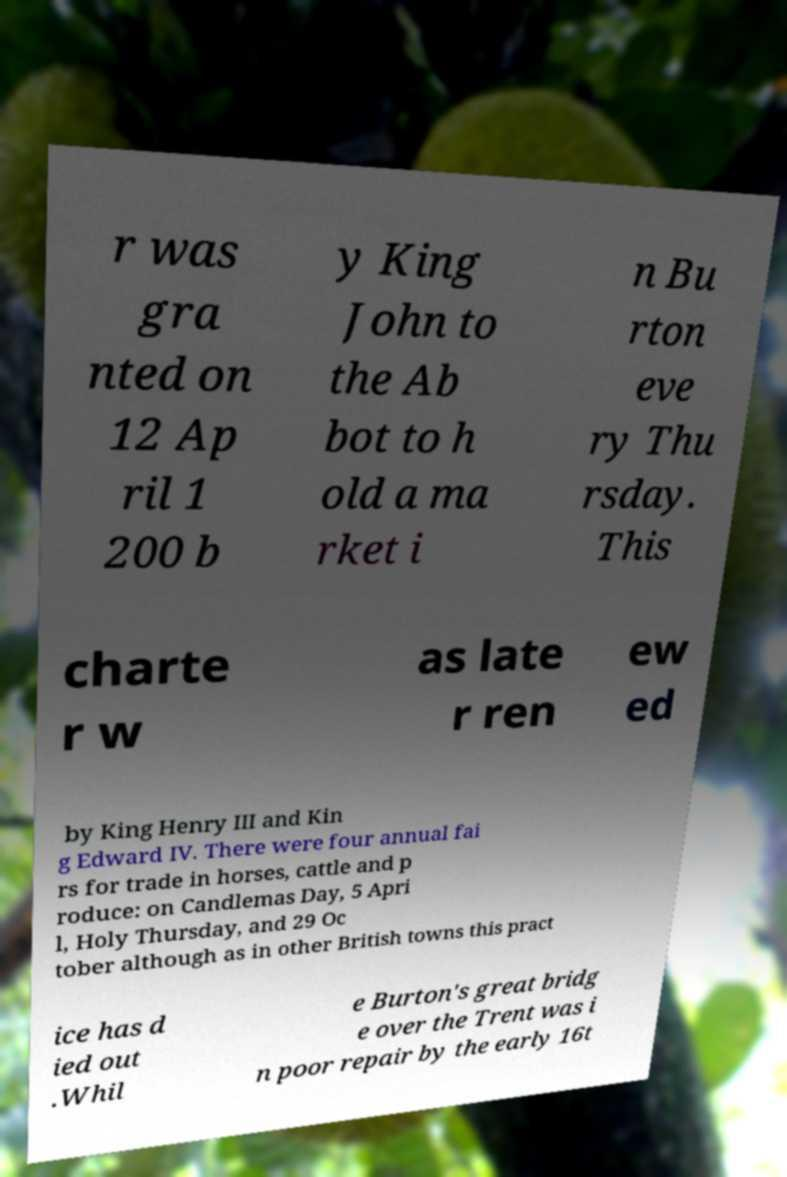Can you accurately transcribe the text from the provided image for me? r was gra nted on 12 Ap ril 1 200 b y King John to the Ab bot to h old a ma rket i n Bu rton eve ry Thu rsday. This charte r w as late r ren ew ed by King Henry III and Kin g Edward IV. There were four annual fai rs for trade in horses, cattle and p roduce: on Candlemas Day, 5 Apri l, Holy Thursday, and 29 Oc tober although as in other British towns this pract ice has d ied out .Whil e Burton's great bridg e over the Trent was i n poor repair by the early 16t 